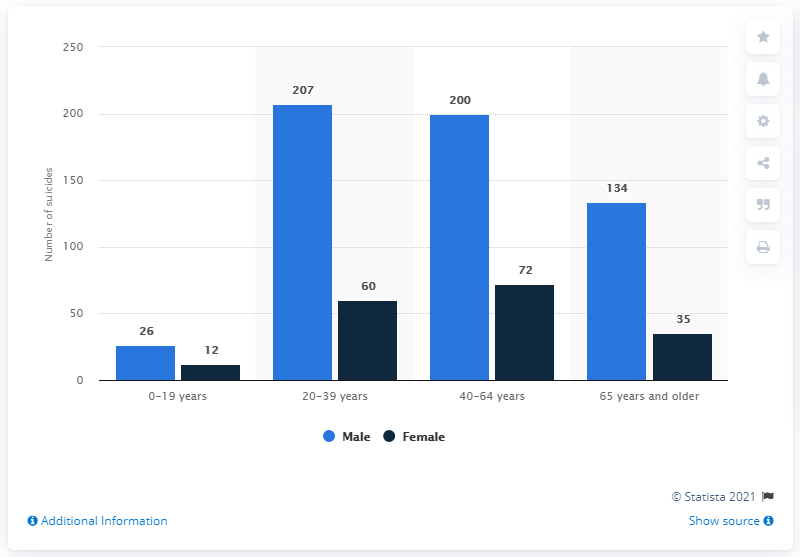Outline some significant characteristics in this image. The difference between the highest male and lowest female in the dataset is 195. According to the given statistic, there were a certain number of suicides reported among men in the specified age group. There are 4 categories of age indicated. According to reported suicides among women, there were 72 cases. 